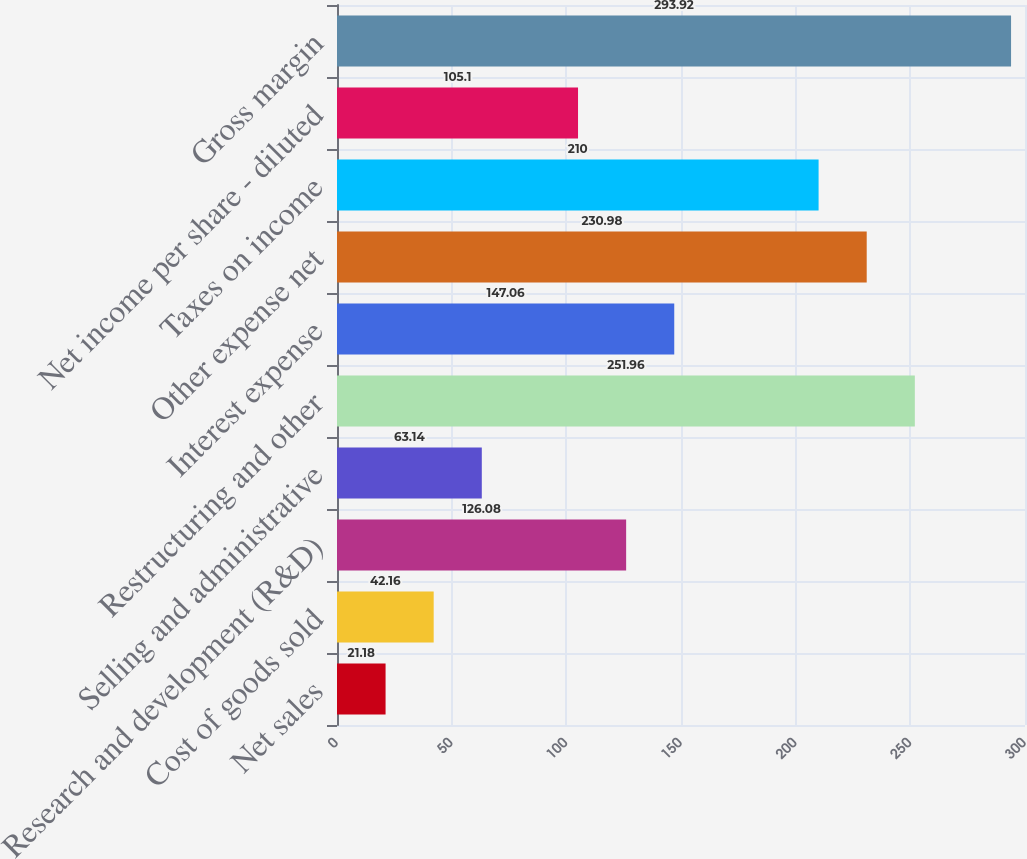Convert chart to OTSL. <chart><loc_0><loc_0><loc_500><loc_500><bar_chart><fcel>Net sales<fcel>Cost of goods sold<fcel>Research and development (R&D)<fcel>Selling and administrative<fcel>Restructuring and other<fcel>Interest expense<fcel>Other expense net<fcel>Taxes on income<fcel>Net income per share - diluted<fcel>Gross margin<nl><fcel>21.18<fcel>42.16<fcel>126.08<fcel>63.14<fcel>251.96<fcel>147.06<fcel>230.98<fcel>210<fcel>105.1<fcel>293.92<nl></chart> 